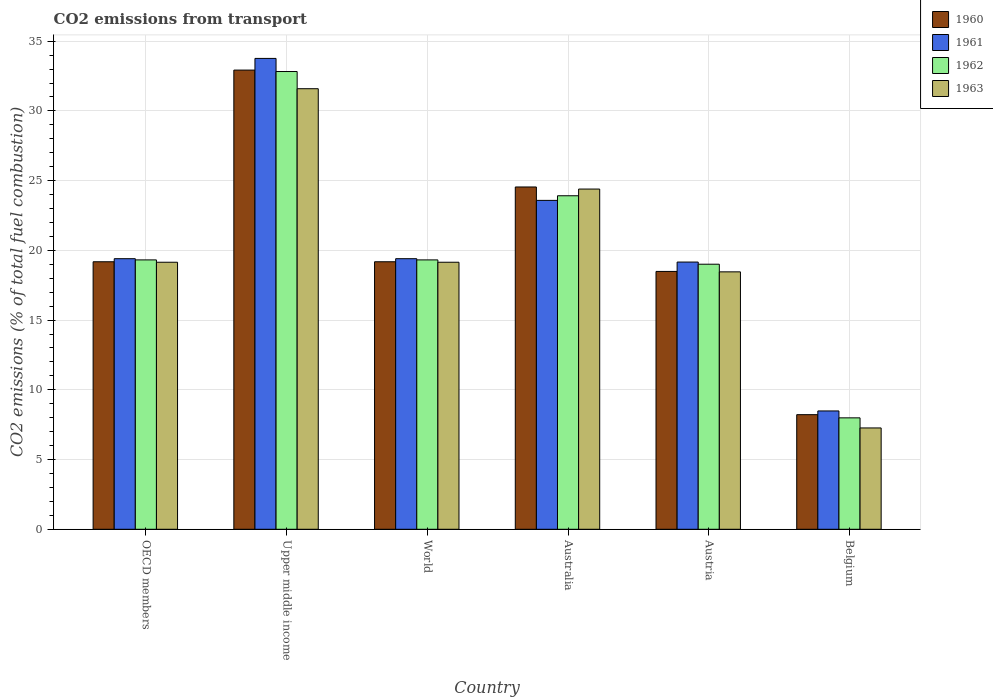Are the number of bars per tick equal to the number of legend labels?
Provide a short and direct response. Yes. How many bars are there on the 2nd tick from the left?
Give a very brief answer. 4. How many bars are there on the 1st tick from the right?
Make the answer very short. 4. What is the label of the 3rd group of bars from the left?
Your response must be concise. World. What is the total CO2 emitted in 1960 in World?
Give a very brief answer. 19.18. Across all countries, what is the maximum total CO2 emitted in 1960?
Keep it short and to the point. 32.93. Across all countries, what is the minimum total CO2 emitted in 1963?
Offer a terse response. 7.27. In which country was the total CO2 emitted in 1962 maximum?
Ensure brevity in your answer.  Upper middle income. In which country was the total CO2 emitted in 1961 minimum?
Provide a succinct answer. Belgium. What is the total total CO2 emitted in 1960 in the graph?
Keep it short and to the point. 122.55. What is the difference between the total CO2 emitted in 1961 in Austria and that in World?
Your response must be concise. -0.24. What is the difference between the total CO2 emitted in 1962 in Australia and the total CO2 emitted in 1963 in Austria?
Provide a succinct answer. 5.46. What is the average total CO2 emitted in 1962 per country?
Your answer should be compact. 20.4. What is the difference between the total CO2 emitted of/in 1961 and total CO2 emitted of/in 1962 in World?
Offer a very short reply. 0.09. In how many countries, is the total CO2 emitted in 1962 greater than 34?
Keep it short and to the point. 0. What is the ratio of the total CO2 emitted in 1961 in Australia to that in Austria?
Provide a succinct answer. 1.23. Is the difference between the total CO2 emitted in 1961 in OECD members and Upper middle income greater than the difference between the total CO2 emitted in 1962 in OECD members and Upper middle income?
Your answer should be very brief. No. What is the difference between the highest and the second highest total CO2 emitted in 1962?
Your response must be concise. 13.51. What is the difference between the highest and the lowest total CO2 emitted in 1960?
Provide a short and direct response. 24.71. What does the 1st bar from the left in World represents?
Keep it short and to the point. 1960. Is it the case that in every country, the sum of the total CO2 emitted in 1963 and total CO2 emitted in 1961 is greater than the total CO2 emitted in 1960?
Your answer should be compact. Yes. Are all the bars in the graph horizontal?
Offer a very short reply. No. How many countries are there in the graph?
Your response must be concise. 6. Are the values on the major ticks of Y-axis written in scientific E-notation?
Your answer should be compact. No. Does the graph contain any zero values?
Offer a terse response. No. Does the graph contain grids?
Your answer should be compact. Yes. Where does the legend appear in the graph?
Your answer should be very brief. Top right. What is the title of the graph?
Provide a short and direct response. CO2 emissions from transport. Does "2000" appear as one of the legend labels in the graph?
Your response must be concise. No. What is the label or title of the X-axis?
Keep it short and to the point. Country. What is the label or title of the Y-axis?
Your answer should be very brief. CO2 emissions (% of total fuel combustion). What is the CO2 emissions (% of total fuel combustion) of 1960 in OECD members?
Provide a short and direct response. 19.18. What is the CO2 emissions (% of total fuel combustion) of 1961 in OECD members?
Give a very brief answer. 19.4. What is the CO2 emissions (% of total fuel combustion) in 1962 in OECD members?
Ensure brevity in your answer.  19.32. What is the CO2 emissions (% of total fuel combustion) in 1963 in OECD members?
Your response must be concise. 19.15. What is the CO2 emissions (% of total fuel combustion) in 1960 in Upper middle income?
Your answer should be compact. 32.93. What is the CO2 emissions (% of total fuel combustion) of 1961 in Upper middle income?
Ensure brevity in your answer.  33.76. What is the CO2 emissions (% of total fuel combustion) of 1962 in Upper middle income?
Provide a succinct answer. 32.82. What is the CO2 emissions (% of total fuel combustion) of 1963 in Upper middle income?
Your answer should be very brief. 31.59. What is the CO2 emissions (% of total fuel combustion) in 1960 in World?
Your answer should be compact. 19.18. What is the CO2 emissions (% of total fuel combustion) in 1961 in World?
Give a very brief answer. 19.4. What is the CO2 emissions (% of total fuel combustion) of 1962 in World?
Ensure brevity in your answer.  19.32. What is the CO2 emissions (% of total fuel combustion) in 1963 in World?
Your answer should be compact. 19.15. What is the CO2 emissions (% of total fuel combustion) of 1960 in Australia?
Your answer should be compact. 24.55. What is the CO2 emissions (% of total fuel combustion) of 1961 in Australia?
Make the answer very short. 23.59. What is the CO2 emissions (% of total fuel combustion) in 1962 in Australia?
Your answer should be compact. 23.92. What is the CO2 emissions (% of total fuel combustion) in 1963 in Australia?
Your answer should be compact. 24.4. What is the CO2 emissions (% of total fuel combustion) of 1960 in Austria?
Offer a terse response. 18.49. What is the CO2 emissions (% of total fuel combustion) in 1961 in Austria?
Keep it short and to the point. 19.16. What is the CO2 emissions (% of total fuel combustion) in 1962 in Austria?
Your answer should be compact. 19.01. What is the CO2 emissions (% of total fuel combustion) in 1963 in Austria?
Your answer should be very brief. 18.46. What is the CO2 emissions (% of total fuel combustion) of 1960 in Belgium?
Provide a short and direct response. 8.22. What is the CO2 emissions (% of total fuel combustion) of 1961 in Belgium?
Your answer should be very brief. 8.49. What is the CO2 emissions (% of total fuel combustion) of 1962 in Belgium?
Your answer should be compact. 7.99. What is the CO2 emissions (% of total fuel combustion) in 1963 in Belgium?
Provide a short and direct response. 7.27. Across all countries, what is the maximum CO2 emissions (% of total fuel combustion) of 1960?
Offer a terse response. 32.93. Across all countries, what is the maximum CO2 emissions (% of total fuel combustion) in 1961?
Offer a terse response. 33.76. Across all countries, what is the maximum CO2 emissions (% of total fuel combustion) in 1962?
Offer a very short reply. 32.82. Across all countries, what is the maximum CO2 emissions (% of total fuel combustion) in 1963?
Offer a very short reply. 31.59. Across all countries, what is the minimum CO2 emissions (% of total fuel combustion) in 1960?
Give a very brief answer. 8.22. Across all countries, what is the minimum CO2 emissions (% of total fuel combustion) in 1961?
Offer a terse response. 8.49. Across all countries, what is the minimum CO2 emissions (% of total fuel combustion) of 1962?
Offer a terse response. 7.99. Across all countries, what is the minimum CO2 emissions (% of total fuel combustion) of 1963?
Offer a very short reply. 7.27. What is the total CO2 emissions (% of total fuel combustion) of 1960 in the graph?
Offer a terse response. 122.55. What is the total CO2 emissions (% of total fuel combustion) in 1961 in the graph?
Your response must be concise. 123.8. What is the total CO2 emissions (% of total fuel combustion) in 1962 in the graph?
Offer a very short reply. 122.37. What is the total CO2 emissions (% of total fuel combustion) in 1963 in the graph?
Provide a succinct answer. 120.01. What is the difference between the CO2 emissions (% of total fuel combustion) of 1960 in OECD members and that in Upper middle income?
Provide a short and direct response. -13.75. What is the difference between the CO2 emissions (% of total fuel combustion) in 1961 in OECD members and that in Upper middle income?
Your answer should be very brief. -14.36. What is the difference between the CO2 emissions (% of total fuel combustion) of 1962 in OECD members and that in Upper middle income?
Your answer should be very brief. -13.51. What is the difference between the CO2 emissions (% of total fuel combustion) of 1963 in OECD members and that in Upper middle income?
Give a very brief answer. -12.44. What is the difference between the CO2 emissions (% of total fuel combustion) in 1960 in OECD members and that in World?
Keep it short and to the point. 0. What is the difference between the CO2 emissions (% of total fuel combustion) of 1961 in OECD members and that in World?
Make the answer very short. 0. What is the difference between the CO2 emissions (% of total fuel combustion) of 1962 in OECD members and that in World?
Your answer should be compact. 0. What is the difference between the CO2 emissions (% of total fuel combustion) of 1960 in OECD members and that in Australia?
Give a very brief answer. -5.36. What is the difference between the CO2 emissions (% of total fuel combustion) of 1961 in OECD members and that in Australia?
Ensure brevity in your answer.  -4.18. What is the difference between the CO2 emissions (% of total fuel combustion) of 1962 in OECD members and that in Australia?
Provide a short and direct response. -4.6. What is the difference between the CO2 emissions (% of total fuel combustion) of 1963 in OECD members and that in Australia?
Provide a short and direct response. -5.25. What is the difference between the CO2 emissions (% of total fuel combustion) in 1960 in OECD members and that in Austria?
Offer a terse response. 0.69. What is the difference between the CO2 emissions (% of total fuel combustion) in 1961 in OECD members and that in Austria?
Provide a short and direct response. 0.24. What is the difference between the CO2 emissions (% of total fuel combustion) in 1962 in OECD members and that in Austria?
Your answer should be very brief. 0.31. What is the difference between the CO2 emissions (% of total fuel combustion) in 1963 in OECD members and that in Austria?
Make the answer very short. 0.69. What is the difference between the CO2 emissions (% of total fuel combustion) of 1960 in OECD members and that in Belgium?
Provide a short and direct response. 10.96. What is the difference between the CO2 emissions (% of total fuel combustion) in 1961 in OECD members and that in Belgium?
Keep it short and to the point. 10.92. What is the difference between the CO2 emissions (% of total fuel combustion) of 1962 in OECD members and that in Belgium?
Your answer should be compact. 11.33. What is the difference between the CO2 emissions (% of total fuel combustion) in 1963 in OECD members and that in Belgium?
Keep it short and to the point. 11.88. What is the difference between the CO2 emissions (% of total fuel combustion) in 1960 in Upper middle income and that in World?
Provide a succinct answer. 13.75. What is the difference between the CO2 emissions (% of total fuel combustion) in 1961 in Upper middle income and that in World?
Offer a terse response. 14.36. What is the difference between the CO2 emissions (% of total fuel combustion) in 1962 in Upper middle income and that in World?
Your answer should be very brief. 13.51. What is the difference between the CO2 emissions (% of total fuel combustion) of 1963 in Upper middle income and that in World?
Offer a terse response. 12.44. What is the difference between the CO2 emissions (% of total fuel combustion) of 1960 in Upper middle income and that in Australia?
Give a very brief answer. 8.38. What is the difference between the CO2 emissions (% of total fuel combustion) of 1961 in Upper middle income and that in Australia?
Offer a very short reply. 10.18. What is the difference between the CO2 emissions (% of total fuel combustion) of 1962 in Upper middle income and that in Australia?
Provide a short and direct response. 8.91. What is the difference between the CO2 emissions (% of total fuel combustion) in 1963 in Upper middle income and that in Australia?
Your response must be concise. 7.2. What is the difference between the CO2 emissions (% of total fuel combustion) in 1960 in Upper middle income and that in Austria?
Provide a short and direct response. 14.44. What is the difference between the CO2 emissions (% of total fuel combustion) of 1961 in Upper middle income and that in Austria?
Provide a succinct answer. 14.6. What is the difference between the CO2 emissions (% of total fuel combustion) in 1962 in Upper middle income and that in Austria?
Give a very brief answer. 13.82. What is the difference between the CO2 emissions (% of total fuel combustion) of 1963 in Upper middle income and that in Austria?
Offer a terse response. 13.13. What is the difference between the CO2 emissions (% of total fuel combustion) in 1960 in Upper middle income and that in Belgium?
Provide a short and direct response. 24.71. What is the difference between the CO2 emissions (% of total fuel combustion) of 1961 in Upper middle income and that in Belgium?
Offer a very short reply. 25.28. What is the difference between the CO2 emissions (% of total fuel combustion) of 1962 in Upper middle income and that in Belgium?
Make the answer very short. 24.83. What is the difference between the CO2 emissions (% of total fuel combustion) in 1963 in Upper middle income and that in Belgium?
Ensure brevity in your answer.  24.33. What is the difference between the CO2 emissions (% of total fuel combustion) in 1960 in World and that in Australia?
Make the answer very short. -5.36. What is the difference between the CO2 emissions (% of total fuel combustion) in 1961 in World and that in Australia?
Offer a terse response. -4.18. What is the difference between the CO2 emissions (% of total fuel combustion) in 1962 in World and that in Australia?
Your answer should be compact. -4.6. What is the difference between the CO2 emissions (% of total fuel combustion) in 1963 in World and that in Australia?
Make the answer very short. -5.25. What is the difference between the CO2 emissions (% of total fuel combustion) in 1960 in World and that in Austria?
Make the answer very short. 0.69. What is the difference between the CO2 emissions (% of total fuel combustion) in 1961 in World and that in Austria?
Ensure brevity in your answer.  0.24. What is the difference between the CO2 emissions (% of total fuel combustion) of 1962 in World and that in Austria?
Your answer should be compact. 0.31. What is the difference between the CO2 emissions (% of total fuel combustion) of 1963 in World and that in Austria?
Keep it short and to the point. 0.69. What is the difference between the CO2 emissions (% of total fuel combustion) in 1960 in World and that in Belgium?
Keep it short and to the point. 10.96. What is the difference between the CO2 emissions (% of total fuel combustion) of 1961 in World and that in Belgium?
Ensure brevity in your answer.  10.92. What is the difference between the CO2 emissions (% of total fuel combustion) in 1962 in World and that in Belgium?
Offer a very short reply. 11.33. What is the difference between the CO2 emissions (% of total fuel combustion) in 1963 in World and that in Belgium?
Your answer should be very brief. 11.88. What is the difference between the CO2 emissions (% of total fuel combustion) in 1960 in Australia and that in Austria?
Your answer should be very brief. 6.06. What is the difference between the CO2 emissions (% of total fuel combustion) of 1961 in Australia and that in Austria?
Provide a short and direct response. 4.42. What is the difference between the CO2 emissions (% of total fuel combustion) in 1962 in Australia and that in Austria?
Provide a short and direct response. 4.91. What is the difference between the CO2 emissions (% of total fuel combustion) of 1963 in Australia and that in Austria?
Provide a succinct answer. 5.94. What is the difference between the CO2 emissions (% of total fuel combustion) in 1960 in Australia and that in Belgium?
Your response must be concise. 16.33. What is the difference between the CO2 emissions (% of total fuel combustion) of 1961 in Australia and that in Belgium?
Your answer should be very brief. 15.1. What is the difference between the CO2 emissions (% of total fuel combustion) of 1962 in Australia and that in Belgium?
Give a very brief answer. 15.93. What is the difference between the CO2 emissions (% of total fuel combustion) in 1963 in Australia and that in Belgium?
Your answer should be very brief. 17.13. What is the difference between the CO2 emissions (% of total fuel combustion) in 1960 in Austria and that in Belgium?
Offer a terse response. 10.27. What is the difference between the CO2 emissions (% of total fuel combustion) of 1961 in Austria and that in Belgium?
Your response must be concise. 10.68. What is the difference between the CO2 emissions (% of total fuel combustion) of 1962 in Austria and that in Belgium?
Provide a succinct answer. 11.02. What is the difference between the CO2 emissions (% of total fuel combustion) in 1963 in Austria and that in Belgium?
Provide a succinct answer. 11.19. What is the difference between the CO2 emissions (% of total fuel combustion) of 1960 in OECD members and the CO2 emissions (% of total fuel combustion) of 1961 in Upper middle income?
Provide a succinct answer. -14.58. What is the difference between the CO2 emissions (% of total fuel combustion) of 1960 in OECD members and the CO2 emissions (% of total fuel combustion) of 1962 in Upper middle income?
Your response must be concise. -13.64. What is the difference between the CO2 emissions (% of total fuel combustion) in 1960 in OECD members and the CO2 emissions (% of total fuel combustion) in 1963 in Upper middle income?
Your answer should be compact. -12.41. What is the difference between the CO2 emissions (% of total fuel combustion) of 1961 in OECD members and the CO2 emissions (% of total fuel combustion) of 1962 in Upper middle income?
Ensure brevity in your answer.  -13.42. What is the difference between the CO2 emissions (% of total fuel combustion) in 1961 in OECD members and the CO2 emissions (% of total fuel combustion) in 1963 in Upper middle income?
Keep it short and to the point. -12.19. What is the difference between the CO2 emissions (% of total fuel combustion) of 1962 in OECD members and the CO2 emissions (% of total fuel combustion) of 1963 in Upper middle income?
Make the answer very short. -12.28. What is the difference between the CO2 emissions (% of total fuel combustion) of 1960 in OECD members and the CO2 emissions (% of total fuel combustion) of 1961 in World?
Offer a terse response. -0.22. What is the difference between the CO2 emissions (% of total fuel combustion) in 1960 in OECD members and the CO2 emissions (% of total fuel combustion) in 1962 in World?
Offer a terse response. -0.13. What is the difference between the CO2 emissions (% of total fuel combustion) of 1960 in OECD members and the CO2 emissions (% of total fuel combustion) of 1963 in World?
Offer a terse response. 0.03. What is the difference between the CO2 emissions (% of total fuel combustion) in 1961 in OECD members and the CO2 emissions (% of total fuel combustion) in 1962 in World?
Give a very brief answer. 0.09. What is the difference between the CO2 emissions (% of total fuel combustion) in 1961 in OECD members and the CO2 emissions (% of total fuel combustion) in 1963 in World?
Make the answer very short. 0.25. What is the difference between the CO2 emissions (% of total fuel combustion) of 1962 in OECD members and the CO2 emissions (% of total fuel combustion) of 1963 in World?
Your answer should be compact. 0.17. What is the difference between the CO2 emissions (% of total fuel combustion) in 1960 in OECD members and the CO2 emissions (% of total fuel combustion) in 1961 in Australia?
Keep it short and to the point. -4.4. What is the difference between the CO2 emissions (% of total fuel combustion) of 1960 in OECD members and the CO2 emissions (% of total fuel combustion) of 1962 in Australia?
Provide a succinct answer. -4.73. What is the difference between the CO2 emissions (% of total fuel combustion) in 1960 in OECD members and the CO2 emissions (% of total fuel combustion) in 1963 in Australia?
Make the answer very short. -5.21. What is the difference between the CO2 emissions (% of total fuel combustion) of 1961 in OECD members and the CO2 emissions (% of total fuel combustion) of 1962 in Australia?
Your response must be concise. -4.51. What is the difference between the CO2 emissions (% of total fuel combustion) in 1961 in OECD members and the CO2 emissions (% of total fuel combustion) in 1963 in Australia?
Offer a very short reply. -4.99. What is the difference between the CO2 emissions (% of total fuel combustion) of 1962 in OECD members and the CO2 emissions (% of total fuel combustion) of 1963 in Australia?
Your answer should be compact. -5.08. What is the difference between the CO2 emissions (% of total fuel combustion) in 1960 in OECD members and the CO2 emissions (% of total fuel combustion) in 1961 in Austria?
Provide a succinct answer. 0.02. What is the difference between the CO2 emissions (% of total fuel combustion) in 1960 in OECD members and the CO2 emissions (% of total fuel combustion) in 1962 in Austria?
Offer a very short reply. 0.18. What is the difference between the CO2 emissions (% of total fuel combustion) of 1960 in OECD members and the CO2 emissions (% of total fuel combustion) of 1963 in Austria?
Provide a succinct answer. 0.72. What is the difference between the CO2 emissions (% of total fuel combustion) in 1961 in OECD members and the CO2 emissions (% of total fuel combustion) in 1962 in Austria?
Offer a very short reply. 0.4. What is the difference between the CO2 emissions (% of total fuel combustion) in 1961 in OECD members and the CO2 emissions (% of total fuel combustion) in 1963 in Austria?
Your response must be concise. 0.94. What is the difference between the CO2 emissions (% of total fuel combustion) of 1962 in OECD members and the CO2 emissions (% of total fuel combustion) of 1963 in Austria?
Your response must be concise. 0.86. What is the difference between the CO2 emissions (% of total fuel combustion) of 1960 in OECD members and the CO2 emissions (% of total fuel combustion) of 1961 in Belgium?
Provide a succinct answer. 10.7. What is the difference between the CO2 emissions (% of total fuel combustion) of 1960 in OECD members and the CO2 emissions (% of total fuel combustion) of 1962 in Belgium?
Ensure brevity in your answer.  11.19. What is the difference between the CO2 emissions (% of total fuel combustion) in 1960 in OECD members and the CO2 emissions (% of total fuel combustion) in 1963 in Belgium?
Provide a succinct answer. 11.92. What is the difference between the CO2 emissions (% of total fuel combustion) of 1961 in OECD members and the CO2 emissions (% of total fuel combustion) of 1962 in Belgium?
Your answer should be compact. 11.41. What is the difference between the CO2 emissions (% of total fuel combustion) in 1961 in OECD members and the CO2 emissions (% of total fuel combustion) in 1963 in Belgium?
Make the answer very short. 12.14. What is the difference between the CO2 emissions (% of total fuel combustion) in 1962 in OECD members and the CO2 emissions (% of total fuel combustion) in 1963 in Belgium?
Ensure brevity in your answer.  12.05. What is the difference between the CO2 emissions (% of total fuel combustion) in 1960 in Upper middle income and the CO2 emissions (% of total fuel combustion) in 1961 in World?
Keep it short and to the point. 13.53. What is the difference between the CO2 emissions (% of total fuel combustion) in 1960 in Upper middle income and the CO2 emissions (% of total fuel combustion) in 1962 in World?
Keep it short and to the point. 13.61. What is the difference between the CO2 emissions (% of total fuel combustion) of 1960 in Upper middle income and the CO2 emissions (% of total fuel combustion) of 1963 in World?
Your answer should be compact. 13.78. What is the difference between the CO2 emissions (% of total fuel combustion) in 1961 in Upper middle income and the CO2 emissions (% of total fuel combustion) in 1962 in World?
Your answer should be compact. 14.45. What is the difference between the CO2 emissions (% of total fuel combustion) of 1961 in Upper middle income and the CO2 emissions (% of total fuel combustion) of 1963 in World?
Provide a succinct answer. 14.62. What is the difference between the CO2 emissions (% of total fuel combustion) in 1962 in Upper middle income and the CO2 emissions (% of total fuel combustion) in 1963 in World?
Ensure brevity in your answer.  13.68. What is the difference between the CO2 emissions (% of total fuel combustion) in 1960 in Upper middle income and the CO2 emissions (% of total fuel combustion) in 1961 in Australia?
Ensure brevity in your answer.  9.34. What is the difference between the CO2 emissions (% of total fuel combustion) of 1960 in Upper middle income and the CO2 emissions (% of total fuel combustion) of 1962 in Australia?
Provide a succinct answer. 9.01. What is the difference between the CO2 emissions (% of total fuel combustion) in 1960 in Upper middle income and the CO2 emissions (% of total fuel combustion) in 1963 in Australia?
Your answer should be compact. 8.53. What is the difference between the CO2 emissions (% of total fuel combustion) in 1961 in Upper middle income and the CO2 emissions (% of total fuel combustion) in 1962 in Australia?
Give a very brief answer. 9.85. What is the difference between the CO2 emissions (% of total fuel combustion) in 1961 in Upper middle income and the CO2 emissions (% of total fuel combustion) in 1963 in Australia?
Make the answer very short. 9.37. What is the difference between the CO2 emissions (% of total fuel combustion) of 1962 in Upper middle income and the CO2 emissions (% of total fuel combustion) of 1963 in Australia?
Offer a very short reply. 8.43. What is the difference between the CO2 emissions (% of total fuel combustion) in 1960 in Upper middle income and the CO2 emissions (% of total fuel combustion) in 1961 in Austria?
Your answer should be compact. 13.77. What is the difference between the CO2 emissions (% of total fuel combustion) in 1960 in Upper middle income and the CO2 emissions (% of total fuel combustion) in 1962 in Austria?
Make the answer very short. 13.92. What is the difference between the CO2 emissions (% of total fuel combustion) in 1960 in Upper middle income and the CO2 emissions (% of total fuel combustion) in 1963 in Austria?
Provide a short and direct response. 14.47. What is the difference between the CO2 emissions (% of total fuel combustion) of 1961 in Upper middle income and the CO2 emissions (% of total fuel combustion) of 1962 in Austria?
Offer a terse response. 14.76. What is the difference between the CO2 emissions (% of total fuel combustion) in 1961 in Upper middle income and the CO2 emissions (% of total fuel combustion) in 1963 in Austria?
Your answer should be very brief. 15.3. What is the difference between the CO2 emissions (% of total fuel combustion) of 1962 in Upper middle income and the CO2 emissions (% of total fuel combustion) of 1963 in Austria?
Give a very brief answer. 14.36. What is the difference between the CO2 emissions (% of total fuel combustion) in 1960 in Upper middle income and the CO2 emissions (% of total fuel combustion) in 1961 in Belgium?
Offer a terse response. 24.44. What is the difference between the CO2 emissions (% of total fuel combustion) in 1960 in Upper middle income and the CO2 emissions (% of total fuel combustion) in 1962 in Belgium?
Your response must be concise. 24.94. What is the difference between the CO2 emissions (% of total fuel combustion) of 1960 in Upper middle income and the CO2 emissions (% of total fuel combustion) of 1963 in Belgium?
Offer a very short reply. 25.66. What is the difference between the CO2 emissions (% of total fuel combustion) in 1961 in Upper middle income and the CO2 emissions (% of total fuel combustion) in 1962 in Belgium?
Ensure brevity in your answer.  25.77. What is the difference between the CO2 emissions (% of total fuel combustion) of 1961 in Upper middle income and the CO2 emissions (% of total fuel combustion) of 1963 in Belgium?
Give a very brief answer. 26.5. What is the difference between the CO2 emissions (% of total fuel combustion) of 1962 in Upper middle income and the CO2 emissions (% of total fuel combustion) of 1963 in Belgium?
Keep it short and to the point. 25.56. What is the difference between the CO2 emissions (% of total fuel combustion) of 1960 in World and the CO2 emissions (% of total fuel combustion) of 1961 in Australia?
Provide a short and direct response. -4.4. What is the difference between the CO2 emissions (% of total fuel combustion) of 1960 in World and the CO2 emissions (% of total fuel combustion) of 1962 in Australia?
Make the answer very short. -4.73. What is the difference between the CO2 emissions (% of total fuel combustion) of 1960 in World and the CO2 emissions (% of total fuel combustion) of 1963 in Australia?
Offer a terse response. -5.21. What is the difference between the CO2 emissions (% of total fuel combustion) of 1961 in World and the CO2 emissions (% of total fuel combustion) of 1962 in Australia?
Provide a short and direct response. -4.51. What is the difference between the CO2 emissions (% of total fuel combustion) of 1961 in World and the CO2 emissions (% of total fuel combustion) of 1963 in Australia?
Offer a terse response. -4.99. What is the difference between the CO2 emissions (% of total fuel combustion) in 1962 in World and the CO2 emissions (% of total fuel combustion) in 1963 in Australia?
Offer a very short reply. -5.08. What is the difference between the CO2 emissions (% of total fuel combustion) in 1960 in World and the CO2 emissions (% of total fuel combustion) in 1961 in Austria?
Your answer should be compact. 0.02. What is the difference between the CO2 emissions (% of total fuel combustion) in 1960 in World and the CO2 emissions (% of total fuel combustion) in 1962 in Austria?
Give a very brief answer. 0.18. What is the difference between the CO2 emissions (% of total fuel combustion) of 1960 in World and the CO2 emissions (% of total fuel combustion) of 1963 in Austria?
Provide a succinct answer. 0.72. What is the difference between the CO2 emissions (% of total fuel combustion) in 1961 in World and the CO2 emissions (% of total fuel combustion) in 1962 in Austria?
Make the answer very short. 0.4. What is the difference between the CO2 emissions (% of total fuel combustion) of 1961 in World and the CO2 emissions (% of total fuel combustion) of 1963 in Austria?
Your response must be concise. 0.94. What is the difference between the CO2 emissions (% of total fuel combustion) in 1962 in World and the CO2 emissions (% of total fuel combustion) in 1963 in Austria?
Make the answer very short. 0.86. What is the difference between the CO2 emissions (% of total fuel combustion) of 1960 in World and the CO2 emissions (% of total fuel combustion) of 1961 in Belgium?
Provide a succinct answer. 10.7. What is the difference between the CO2 emissions (% of total fuel combustion) of 1960 in World and the CO2 emissions (% of total fuel combustion) of 1962 in Belgium?
Offer a terse response. 11.19. What is the difference between the CO2 emissions (% of total fuel combustion) in 1960 in World and the CO2 emissions (% of total fuel combustion) in 1963 in Belgium?
Make the answer very short. 11.92. What is the difference between the CO2 emissions (% of total fuel combustion) of 1961 in World and the CO2 emissions (% of total fuel combustion) of 1962 in Belgium?
Make the answer very short. 11.41. What is the difference between the CO2 emissions (% of total fuel combustion) in 1961 in World and the CO2 emissions (% of total fuel combustion) in 1963 in Belgium?
Give a very brief answer. 12.14. What is the difference between the CO2 emissions (% of total fuel combustion) of 1962 in World and the CO2 emissions (% of total fuel combustion) of 1963 in Belgium?
Keep it short and to the point. 12.05. What is the difference between the CO2 emissions (% of total fuel combustion) in 1960 in Australia and the CO2 emissions (% of total fuel combustion) in 1961 in Austria?
Keep it short and to the point. 5.38. What is the difference between the CO2 emissions (% of total fuel combustion) in 1960 in Australia and the CO2 emissions (% of total fuel combustion) in 1962 in Austria?
Provide a short and direct response. 5.54. What is the difference between the CO2 emissions (% of total fuel combustion) in 1960 in Australia and the CO2 emissions (% of total fuel combustion) in 1963 in Austria?
Give a very brief answer. 6.09. What is the difference between the CO2 emissions (% of total fuel combustion) of 1961 in Australia and the CO2 emissions (% of total fuel combustion) of 1962 in Austria?
Provide a short and direct response. 4.58. What is the difference between the CO2 emissions (% of total fuel combustion) in 1961 in Australia and the CO2 emissions (% of total fuel combustion) in 1963 in Austria?
Make the answer very short. 5.13. What is the difference between the CO2 emissions (% of total fuel combustion) in 1962 in Australia and the CO2 emissions (% of total fuel combustion) in 1963 in Austria?
Your response must be concise. 5.46. What is the difference between the CO2 emissions (% of total fuel combustion) in 1960 in Australia and the CO2 emissions (% of total fuel combustion) in 1961 in Belgium?
Provide a short and direct response. 16.06. What is the difference between the CO2 emissions (% of total fuel combustion) of 1960 in Australia and the CO2 emissions (% of total fuel combustion) of 1962 in Belgium?
Ensure brevity in your answer.  16.56. What is the difference between the CO2 emissions (% of total fuel combustion) of 1960 in Australia and the CO2 emissions (% of total fuel combustion) of 1963 in Belgium?
Make the answer very short. 17.28. What is the difference between the CO2 emissions (% of total fuel combustion) in 1961 in Australia and the CO2 emissions (% of total fuel combustion) in 1962 in Belgium?
Your response must be concise. 15.59. What is the difference between the CO2 emissions (% of total fuel combustion) of 1961 in Australia and the CO2 emissions (% of total fuel combustion) of 1963 in Belgium?
Your response must be concise. 16.32. What is the difference between the CO2 emissions (% of total fuel combustion) of 1962 in Australia and the CO2 emissions (% of total fuel combustion) of 1963 in Belgium?
Provide a short and direct response. 16.65. What is the difference between the CO2 emissions (% of total fuel combustion) of 1960 in Austria and the CO2 emissions (% of total fuel combustion) of 1961 in Belgium?
Keep it short and to the point. 10. What is the difference between the CO2 emissions (% of total fuel combustion) of 1960 in Austria and the CO2 emissions (% of total fuel combustion) of 1962 in Belgium?
Ensure brevity in your answer.  10.5. What is the difference between the CO2 emissions (% of total fuel combustion) in 1960 in Austria and the CO2 emissions (% of total fuel combustion) in 1963 in Belgium?
Offer a very short reply. 11.22. What is the difference between the CO2 emissions (% of total fuel combustion) in 1961 in Austria and the CO2 emissions (% of total fuel combustion) in 1962 in Belgium?
Ensure brevity in your answer.  11.17. What is the difference between the CO2 emissions (% of total fuel combustion) of 1961 in Austria and the CO2 emissions (% of total fuel combustion) of 1963 in Belgium?
Provide a short and direct response. 11.9. What is the difference between the CO2 emissions (% of total fuel combustion) in 1962 in Austria and the CO2 emissions (% of total fuel combustion) in 1963 in Belgium?
Provide a succinct answer. 11.74. What is the average CO2 emissions (% of total fuel combustion) in 1960 per country?
Your answer should be very brief. 20.42. What is the average CO2 emissions (% of total fuel combustion) in 1961 per country?
Ensure brevity in your answer.  20.63. What is the average CO2 emissions (% of total fuel combustion) in 1962 per country?
Make the answer very short. 20.4. What is the average CO2 emissions (% of total fuel combustion) in 1963 per country?
Make the answer very short. 20. What is the difference between the CO2 emissions (% of total fuel combustion) in 1960 and CO2 emissions (% of total fuel combustion) in 1961 in OECD members?
Provide a short and direct response. -0.22. What is the difference between the CO2 emissions (% of total fuel combustion) of 1960 and CO2 emissions (% of total fuel combustion) of 1962 in OECD members?
Offer a terse response. -0.13. What is the difference between the CO2 emissions (% of total fuel combustion) in 1960 and CO2 emissions (% of total fuel combustion) in 1963 in OECD members?
Provide a succinct answer. 0.03. What is the difference between the CO2 emissions (% of total fuel combustion) of 1961 and CO2 emissions (% of total fuel combustion) of 1962 in OECD members?
Your answer should be very brief. 0.09. What is the difference between the CO2 emissions (% of total fuel combustion) of 1961 and CO2 emissions (% of total fuel combustion) of 1963 in OECD members?
Offer a terse response. 0.25. What is the difference between the CO2 emissions (% of total fuel combustion) of 1962 and CO2 emissions (% of total fuel combustion) of 1963 in OECD members?
Offer a very short reply. 0.17. What is the difference between the CO2 emissions (% of total fuel combustion) in 1960 and CO2 emissions (% of total fuel combustion) in 1961 in Upper middle income?
Make the answer very short. -0.84. What is the difference between the CO2 emissions (% of total fuel combustion) in 1960 and CO2 emissions (% of total fuel combustion) in 1962 in Upper middle income?
Ensure brevity in your answer.  0.1. What is the difference between the CO2 emissions (% of total fuel combustion) in 1960 and CO2 emissions (% of total fuel combustion) in 1963 in Upper middle income?
Your answer should be compact. 1.34. What is the difference between the CO2 emissions (% of total fuel combustion) of 1961 and CO2 emissions (% of total fuel combustion) of 1962 in Upper middle income?
Offer a terse response. 0.94. What is the difference between the CO2 emissions (% of total fuel combustion) in 1961 and CO2 emissions (% of total fuel combustion) in 1963 in Upper middle income?
Provide a short and direct response. 2.17. What is the difference between the CO2 emissions (% of total fuel combustion) of 1962 and CO2 emissions (% of total fuel combustion) of 1963 in Upper middle income?
Your answer should be very brief. 1.23. What is the difference between the CO2 emissions (% of total fuel combustion) in 1960 and CO2 emissions (% of total fuel combustion) in 1961 in World?
Offer a terse response. -0.22. What is the difference between the CO2 emissions (% of total fuel combustion) of 1960 and CO2 emissions (% of total fuel combustion) of 1962 in World?
Your answer should be compact. -0.13. What is the difference between the CO2 emissions (% of total fuel combustion) in 1960 and CO2 emissions (% of total fuel combustion) in 1963 in World?
Your response must be concise. 0.03. What is the difference between the CO2 emissions (% of total fuel combustion) of 1961 and CO2 emissions (% of total fuel combustion) of 1962 in World?
Offer a very short reply. 0.09. What is the difference between the CO2 emissions (% of total fuel combustion) in 1961 and CO2 emissions (% of total fuel combustion) in 1963 in World?
Provide a short and direct response. 0.25. What is the difference between the CO2 emissions (% of total fuel combustion) in 1962 and CO2 emissions (% of total fuel combustion) in 1963 in World?
Offer a terse response. 0.17. What is the difference between the CO2 emissions (% of total fuel combustion) in 1960 and CO2 emissions (% of total fuel combustion) in 1961 in Australia?
Keep it short and to the point. 0.96. What is the difference between the CO2 emissions (% of total fuel combustion) of 1960 and CO2 emissions (% of total fuel combustion) of 1962 in Australia?
Ensure brevity in your answer.  0.63. What is the difference between the CO2 emissions (% of total fuel combustion) in 1960 and CO2 emissions (% of total fuel combustion) in 1963 in Australia?
Your response must be concise. 0.15. What is the difference between the CO2 emissions (% of total fuel combustion) of 1961 and CO2 emissions (% of total fuel combustion) of 1962 in Australia?
Ensure brevity in your answer.  -0.33. What is the difference between the CO2 emissions (% of total fuel combustion) of 1961 and CO2 emissions (% of total fuel combustion) of 1963 in Australia?
Keep it short and to the point. -0.81. What is the difference between the CO2 emissions (% of total fuel combustion) of 1962 and CO2 emissions (% of total fuel combustion) of 1963 in Australia?
Your response must be concise. -0.48. What is the difference between the CO2 emissions (% of total fuel combustion) in 1960 and CO2 emissions (% of total fuel combustion) in 1961 in Austria?
Offer a terse response. -0.67. What is the difference between the CO2 emissions (% of total fuel combustion) in 1960 and CO2 emissions (% of total fuel combustion) in 1962 in Austria?
Your answer should be very brief. -0.52. What is the difference between the CO2 emissions (% of total fuel combustion) of 1960 and CO2 emissions (% of total fuel combustion) of 1963 in Austria?
Make the answer very short. 0.03. What is the difference between the CO2 emissions (% of total fuel combustion) of 1961 and CO2 emissions (% of total fuel combustion) of 1962 in Austria?
Ensure brevity in your answer.  0.15. What is the difference between the CO2 emissions (% of total fuel combustion) of 1961 and CO2 emissions (% of total fuel combustion) of 1963 in Austria?
Make the answer very short. 0.7. What is the difference between the CO2 emissions (% of total fuel combustion) of 1962 and CO2 emissions (% of total fuel combustion) of 1963 in Austria?
Make the answer very short. 0.55. What is the difference between the CO2 emissions (% of total fuel combustion) of 1960 and CO2 emissions (% of total fuel combustion) of 1961 in Belgium?
Offer a terse response. -0.27. What is the difference between the CO2 emissions (% of total fuel combustion) of 1960 and CO2 emissions (% of total fuel combustion) of 1962 in Belgium?
Your answer should be very brief. 0.23. What is the difference between the CO2 emissions (% of total fuel combustion) of 1960 and CO2 emissions (% of total fuel combustion) of 1963 in Belgium?
Your answer should be very brief. 0.95. What is the difference between the CO2 emissions (% of total fuel combustion) of 1961 and CO2 emissions (% of total fuel combustion) of 1962 in Belgium?
Ensure brevity in your answer.  0.49. What is the difference between the CO2 emissions (% of total fuel combustion) in 1961 and CO2 emissions (% of total fuel combustion) in 1963 in Belgium?
Make the answer very short. 1.22. What is the difference between the CO2 emissions (% of total fuel combustion) in 1962 and CO2 emissions (% of total fuel combustion) in 1963 in Belgium?
Your response must be concise. 0.72. What is the ratio of the CO2 emissions (% of total fuel combustion) in 1960 in OECD members to that in Upper middle income?
Keep it short and to the point. 0.58. What is the ratio of the CO2 emissions (% of total fuel combustion) in 1961 in OECD members to that in Upper middle income?
Offer a terse response. 0.57. What is the ratio of the CO2 emissions (% of total fuel combustion) of 1962 in OECD members to that in Upper middle income?
Keep it short and to the point. 0.59. What is the ratio of the CO2 emissions (% of total fuel combustion) of 1963 in OECD members to that in Upper middle income?
Give a very brief answer. 0.61. What is the ratio of the CO2 emissions (% of total fuel combustion) of 1961 in OECD members to that in World?
Your answer should be compact. 1. What is the ratio of the CO2 emissions (% of total fuel combustion) of 1963 in OECD members to that in World?
Offer a very short reply. 1. What is the ratio of the CO2 emissions (% of total fuel combustion) of 1960 in OECD members to that in Australia?
Make the answer very short. 0.78. What is the ratio of the CO2 emissions (% of total fuel combustion) of 1961 in OECD members to that in Australia?
Ensure brevity in your answer.  0.82. What is the ratio of the CO2 emissions (% of total fuel combustion) of 1962 in OECD members to that in Australia?
Make the answer very short. 0.81. What is the ratio of the CO2 emissions (% of total fuel combustion) of 1963 in OECD members to that in Australia?
Provide a short and direct response. 0.78. What is the ratio of the CO2 emissions (% of total fuel combustion) of 1960 in OECD members to that in Austria?
Your answer should be compact. 1.04. What is the ratio of the CO2 emissions (% of total fuel combustion) of 1961 in OECD members to that in Austria?
Your response must be concise. 1.01. What is the ratio of the CO2 emissions (% of total fuel combustion) of 1962 in OECD members to that in Austria?
Provide a succinct answer. 1.02. What is the ratio of the CO2 emissions (% of total fuel combustion) of 1963 in OECD members to that in Austria?
Offer a very short reply. 1.04. What is the ratio of the CO2 emissions (% of total fuel combustion) of 1960 in OECD members to that in Belgium?
Your answer should be compact. 2.33. What is the ratio of the CO2 emissions (% of total fuel combustion) of 1961 in OECD members to that in Belgium?
Make the answer very short. 2.29. What is the ratio of the CO2 emissions (% of total fuel combustion) in 1962 in OECD members to that in Belgium?
Ensure brevity in your answer.  2.42. What is the ratio of the CO2 emissions (% of total fuel combustion) in 1963 in OECD members to that in Belgium?
Your answer should be very brief. 2.64. What is the ratio of the CO2 emissions (% of total fuel combustion) of 1960 in Upper middle income to that in World?
Offer a terse response. 1.72. What is the ratio of the CO2 emissions (% of total fuel combustion) of 1961 in Upper middle income to that in World?
Offer a very short reply. 1.74. What is the ratio of the CO2 emissions (% of total fuel combustion) in 1962 in Upper middle income to that in World?
Ensure brevity in your answer.  1.7. What is the ratio of the CO2 emissions (% of total fuel combustion) in 1963 in Upper middle income to that in World?
Provide a short and direct response. 1.65. What is the ratio of the CO2 emissions (% of total fuel combustion) of 1960 in Upper middle income to that in Australia?
Your answer should be very brief. 1.34. What is the ratio of the CO2 emissions (% of total fuel combustion) in 1961 in Upper middle income to that in Australia?
Ensure brevity in your answer.  1.43. What is the ratio of the CO2 emissions (% of total fuel combustion) in 1962 in Upper middle income to that in Australia?
Provide a short and direct response. 1.37. What is the ratio of the CO2 emissions (% of total fuel combustion) of 1963 in Upper middle income to that in Australia?
Your answer should be compact. 1.29. What is the ratio of the CO2 emissions (% of total fuel combustion) in 1960 in Upper middle income to that in Austria?
Offer a terse response. 1.78. What is the ratio of the CO2 emissions (% of total fuel combustion) in 1961 in Upper middle income to that in Austria?
Provide a short and direct response. 1.76. What is the ratio of the CO2 emissions (% of total fuel combustion) in 1962 in Upper middle income to that in Austria?
Your response must be concise. 1.73. What is the ratio of the CO2 emissions (% of total fuel combustion) in 1963 in Upper middle income to that in Austria?
Your answer should be very brief. 1.71. What is the ratio of the CO2 emissions (% of total fuel combustion) in 1960 in Upper middle income to that in Belgium?
Give a very brief answer. 4.01. What is the ratio of the CO2 emissions (% of total fuel combustion) of 1961 in Upper middle income to that in Belgium?
Provide a short and direct response. 3.98. What is the ratio of the CO2 emissions (% of total fuel combustion) in 1962 in Upper middle income to that in Belgium?
Offer a terse response. 4.11. What is the ratio of the CO2 emissions (% of total fuel combustion) in 1963 in Upper middle income to that in Belgium?
Your answer should be very brief. 4.35. What is the ratio of the CO2 emissions (% of total fuel combustion) in 1960 in World to that in Australia?
Keep it short and to the point. 0.78. What is the ratio of the CO2 emissions (% of total fuel combustion) of 1961 in World to that in Australia?
Keep it short and to the point. 0.82. What is the ratio of the CO2 emissions (% of total fuel combustion) of 1962 in World to that in Australia?
Make the answer very short. 0.81. What is the ratio of the CO2 emissions (% of total fuel combustion) in 1963 in World to that in Australia?
Offer a terse response. 0.78. What is the ratio of the CO2 emissions (% of total fuel combustion) in 1960 in World to that in Austria?
Your answer should be compact. 1.04. What is the ratio of the CO2 emissions (% of total fuel combustion) in 1961 in World to that in Austria?
Your answer should be very brief. 1.01. What is the ratio of the CO2 emissions (% of total fuel combustion) in 1962 in World to that in Austria?
Offer a terse response. 1.02. What is the ratio of the CO2 emissions (% of total fuel combustion) of 1963 in World to that in Austria?
Give a very brief answer. 1.04. What is the ratio of the CO2 emissions (% of total fuel combustion) of 1960 in World to that in Belgium?
Your answer should be compact. 2.33. What is the ratio of the CO2 emissions (% of total fuel combustion) of 1961 in World to that in Belgium?
Keep it short and to the point. 2.29. What is the ratio of the CO2 emissions (% of total fuel combustion) of 1962 in World to that in Belgium?
Ensure brevity in your answer.  2.42. What is the ratio of the CO2 emissions (% of total fuel combustion) of 1963 in World to that in Belgium?
Give a very brief answer. 2.64. What is the ratio of the CO2 emissions (% of total fuel combustion) of 1960 in Australia to that in Austria?
Provide a succinct answer. 1.33. What is the ratio of the CO2 emissions (% of total fuel combustion) in 1961 in Australia to that in Austria?
Offer a very short reply. 1.23. What is the ratio of the CO2 emissions (% of total fuel combustion) in 1962 in Australia to that in Austria?
Your answer should be compact. 1.26. What is the ratio of the CO2 emissions (% of total fuel combustion) of 1963 in Australia to that in Austria?
Offer a very short reply. 1.32. What is the ratio of the CO2 emissions (% of total fuel combustion) in 1960 in Australia to that in Belgium?
Give a very brief answer. 2.99. What is the ratio of the CO2 emissions (% of total fuel combustion) of 1961 in Australia to that in Belgium?
Make the answer very short. 2.78. What is the ratio of the CO2 emissions (% of total fuel combustion) of 1962 in Australia to that in Belgium?
Provide a short and direct response. 2.99. What is the ratio of the CO2 emissions (% of total fuel combustion) of 1963 in Australia to that in Belgium?
Offer a terse response. 3.36. What is the ratio of the CO2 emissions (% of total fuel combustion) in 1960 in Austria to that in Belgium?
Your answer should be compact. 2.25. What is the ratio of the CO2 emissions (% of total fuel combustion) in 1961 in Austria to that in Belgium?
Give a very brief answer. 2.26. What is the ratio of the CO2 emissions (% of total fuel combustion) in 1962 in Austria to that in Belgium?
Keep it short and to the point. 2.38. What is the ratio of the CO2 emissions (% of total fuel combustion) of 1963 in Austria to that in Belgium?
Give a very brief answer. 2.54. What is the difference between the highest and the second highest CO2 emissions (% of total fuel combustion) of 1960?
Provide a short and direct response. 8.38. What is the difference between the highest and the second highest CO2 emissions (% of total fuel combustion) in 1961?
Your answer should be compact. 10.18. What is the difference between the highest and the second highest CO2 emissions (% of total fuel combustion) of 1962?
Provide a short and direct response. 8.91. What is the difference between the highest and the second highest CO2 emissions (% of total fuel combustion) of 1963?
Offer a very short reply. 7.2. What is the difference between the highest and the lowest CO2 emissions (% of total fuel combustion) of 1960?
Offer a very short reply. 24.71. What is the difference between the highest and the lowest CO2 emissions (% of total fuel combustion) of 1961?
Offer a terse response. 25.28. What is the difference between the highest and the lowest CO2 emissions (% of total fuel combustion) in 1962?
Keep it short and to the point. 24.83. What is the difference between the highest and the lowest CO2 emissions (% of total fuel combustion) in 1963?
Provide a succinct answer. 24.33. 